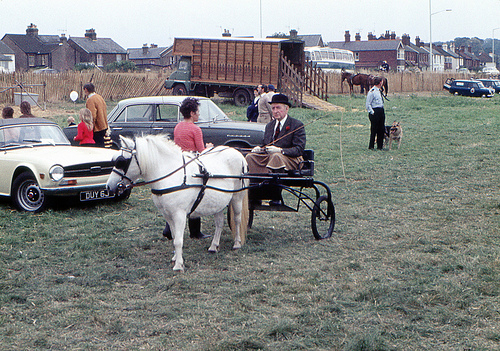How many people are sitting in a buggy? 1 